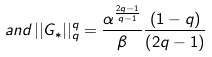Convert formula to latex. <formula><loc_0><loc_0><loc_500><loc_500>a n d \, | | G _ { * } | | _ { q } ^ { q } = \frac { \alpha ^ { \frac { 2 q - 1 } { q - 1 } } } { \beta } \frac { \left ( 1 - q \right ) } { \left ( 2 q - 1 \right ) }</formula> 